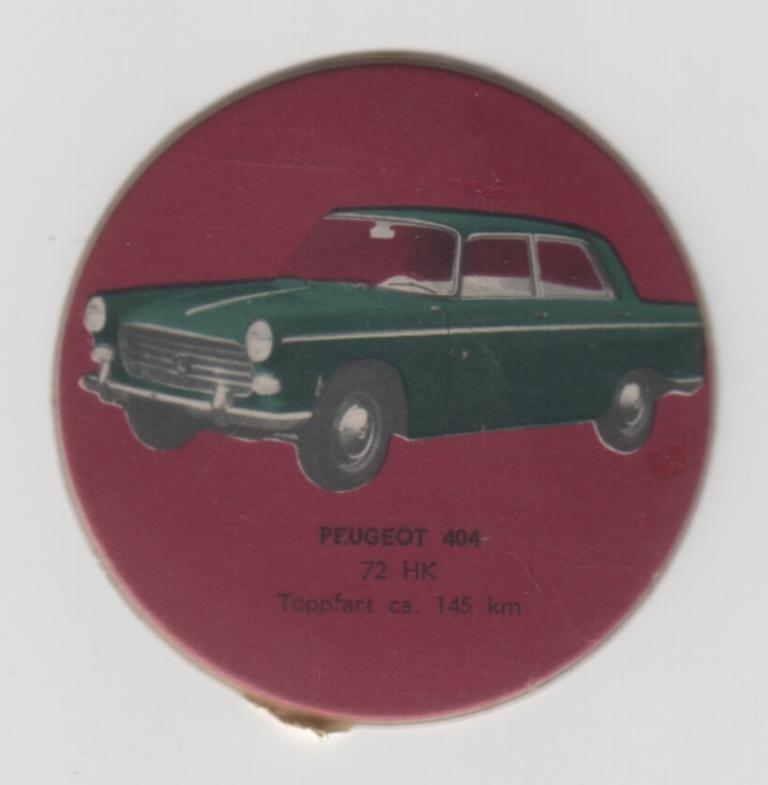What is depicted in the painting in the image? There is a painting of a car on a red surface. What else can be seen on the red surface besides the painting? There is something written on the red surface. What color is the background of the image? The background of the image is white. What type of linen is used to cover the car in the painting? There is no linen present in the image, and the painting does not depict a car being covered. 